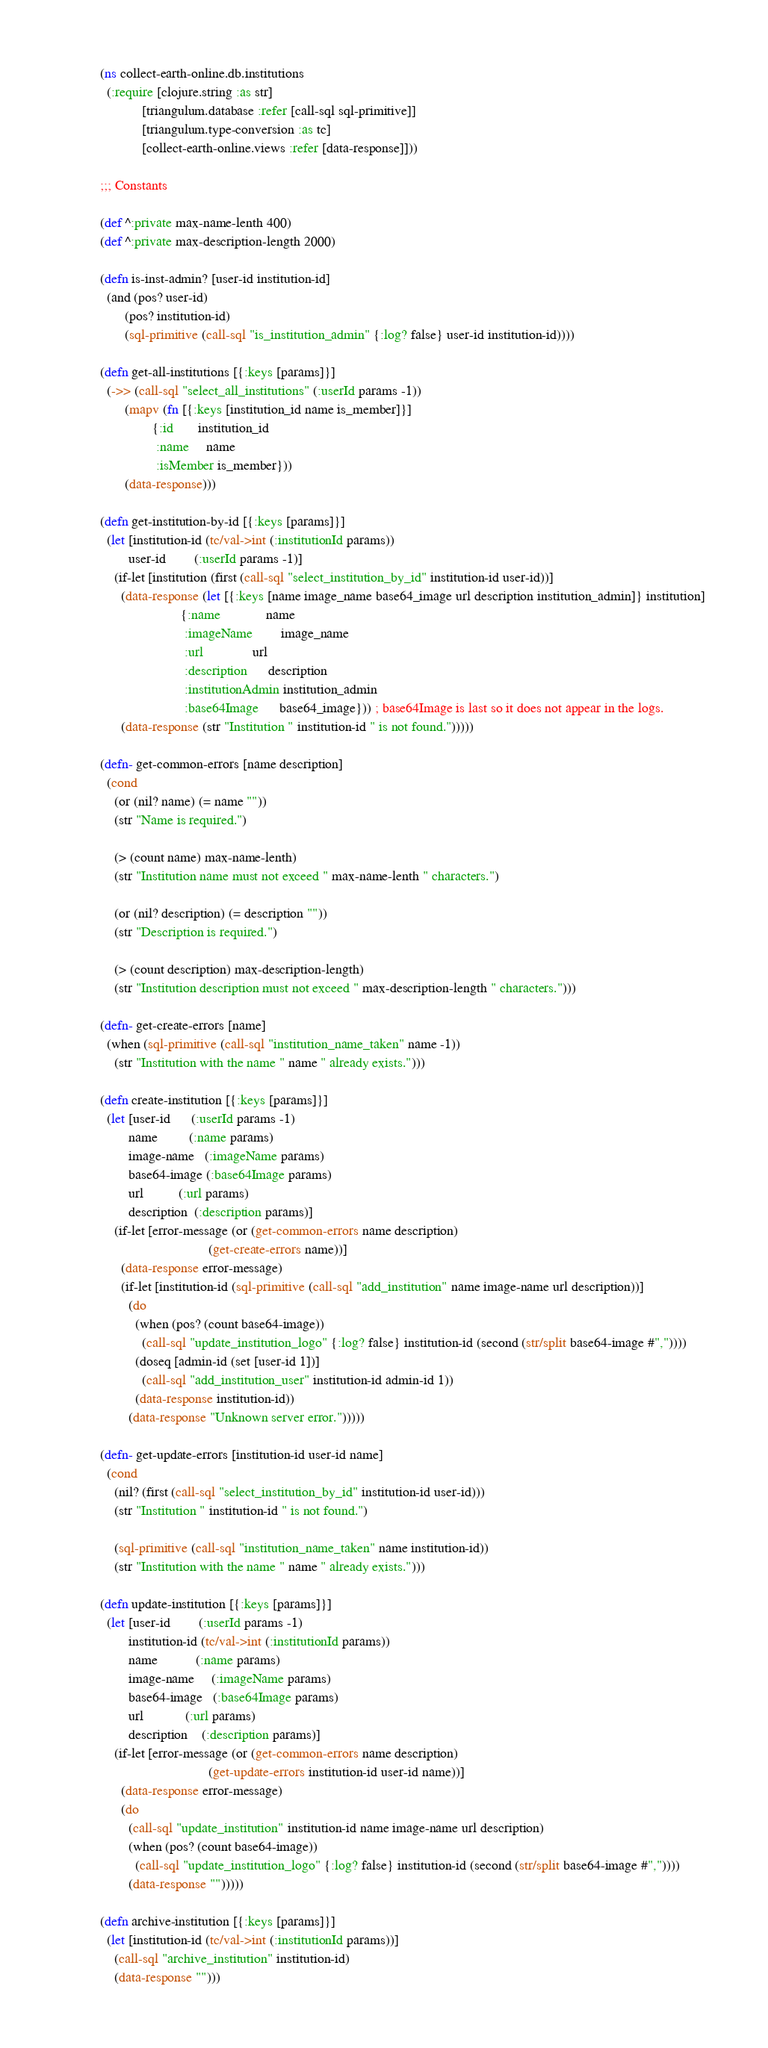<code> <loc_0><loc_0><loc_500><loc_500><_Clojure_>(ns collect-earth-online.db.institutions
  (:require [clojure.string :as str]
            [triangulum.database :refer [call-sql sql-primitive]]
            [triangulum.type-conversion :as tc]
            [collect-earth-online.views :refer [data-response]]))

;;; Constants

(def ^:private max-name-lenth 400)
(def ^:private max-description-length 2000)

(defn is-inst-admin? [user-id institution-id]
  (and (pos? user-id)
       (pos? institution-id)
       (sql-primitive (call-sql "is_institution_admin" {:log? false} user-id institution-id))))

(defn get-all-institutions [{:keys [params]}]
  (->> (call-sql "select_all_institutions" (:userId params -1))
       (mapv (fn [{:keys [institution_id name is_member]}]
               {:id       institution_id
                :name     name
                :isMember is_member}))
       (data-response)))

(defn get-institution-by-id [{:keys [params]}]
  (let [institution-id (tc/val->int (:institutionId params))
        user-id        (:userId params -1)]
    (if-let [institution (first (call-sql "select_institution_by_id" institution-id user-id))]
      (data-response (let [{:keys [name image_name base64_image url description institution_admin]} institution]
                       {:name             name
                        :imageName        image_name
                        :url              url
                        :description      description
                        :institutionAdmin institution_admin
                        :base64Image      base64_image})) ; base64Image is last so it does not appear in the logs.
      (data-response (str "Institution " institution-id " is not found.")))))

(defn- get-common-errors [name description]
  (cond
    (or (nil? name) (= name ""))
    (str "Name is required.")

    (> (count name) max-name-lenth)
    (str "Institution name must not exceed " max-name-lenth " characters.")

    (or (nil? description) (= description ""))
    (str "Description is required.")

    (> (count description) max-description-length)
    (str "Institution description must not exceed " max-description-length " characters.")))

(defn- get-create-errors [name]
  (when (sql-primitive (call-sql "institution_name_taken" name -1))
    (str "Institution with the name " name " already exists.")))

(defn create-institution [{:keys [params]}]
  (let [user-id      (:userId params -1)
        name         (:name params)
        image-name   (:imageName params)
        base64-image (:base64Image params)
        url          (:url params)
        description  (:description params)]
    (if-let [error-message (or (get-common-errors name description)
                               (get-create-errors name))]
      (data-response error-message)
      (if-let [institution-id (sql-primitive (call-sql "add_institution" name image-name url description))]
        (do
          (when (pos? (count base64-image))
            (call-sql "update_institution_logo" {:log? false} institution-id (second (str/split base64-image #","))))
          (doseq [admin-id (set [user-id 1])]
            (call-sql "add_institution_user" institution-id admin-id 1))
          (data-response institution-id))
        (data-response "Unknown server error.")))))

(defn- get-update-errors [institution-id user-id name]
  (cond
    (nil? (first (call-sql "select_institution_by_id" institution-id user-id)))
    (str "Institution " institution-id " is not found.")

    (sql-primitive (call-sql "institution_name_taken" name institution-id))
    (str "Institution with the name " name " already exists.")))

(defn update-institution [{:keys [params]}]
  (let [user-id        (:userId params -1)
        institution-id (tc/val->int (:institutionId params))
        name           (:name params)
        image-name     (:imageName params)
        base64-image   (:base64Image params)
        url            (:url params)
        description    (:description params)]
    (if-let [error-message (or (get-common-errors name description)
                               (get-update-errors institution-id user-id name))]
      (data-response error-message)
      (do
        (call-sql "update_institution" institution-id name image-name url description)
        (when (pos? (count base64-image))
          (call-sql "update_institution_logo" {:log? false} institution-id (second (str/split base64-image #","))))
        (data-response "")))))

(defn archive-institution [{:keys [params]}]
  (let [institution-id (tc/val->int (:institutionId params))]
    (call-sql "archive_institution" institution-id)
    (data-response "")))
</code> 